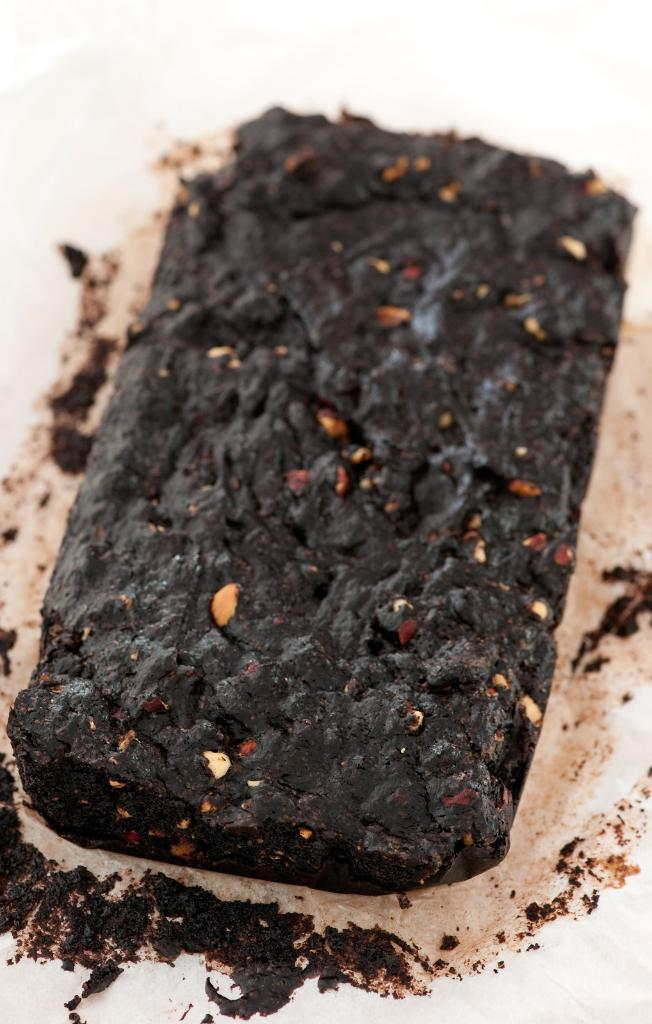What is the main subject of the image? There is a brownie in the center of the image. What reason does the kitty have for being in the wilderness in the image? There is no kitty or wilderness present in the image; it only features a brownie in the center. 